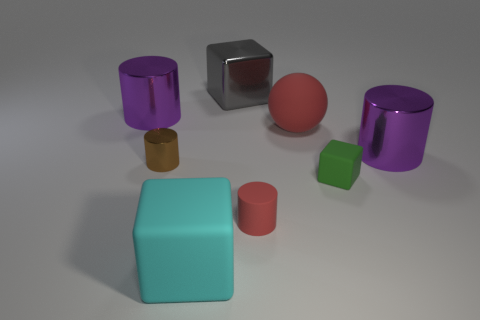Add 1 purple metal objects. How many objects exist? 9 Subtract all rubber blocks. How many blocks are left? 1 Subtract 1 cubes. How many cubes are left? 2 Add 8 purple matte cylinders. How many purple matte cylinders exist? 8 Subtract all brown cylinders. How many cylinders are left? 3 Subtract 1 green blocks. How many objects are left? 7 Subtract all blocks. How many objects are left? 5 Subtract all brown cubes. Subtract all green spheres. How many cubes are left? 3 Subtract all green cylinders. How many gray blocks are left? 1 Subtract all big red matte balls. Subtract all rubber cubes. How many objects are left? 5 